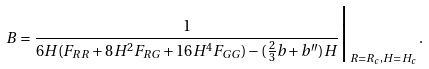<formula> <loc_0><loc_0><loc_500><loc_500>B = \frac { 1 } { 6 H ( F _ { R R } + 8 H ^ { 2 } F _ { R G } + 1 6 H ^ { 4 } F _ { G G } ) - ( \frac { 2 } { 3 } b + b ^ { \prime \prime } ) H } \Big | _ { R = R _ { c } , H = H _ { c } } \, .</formula> 